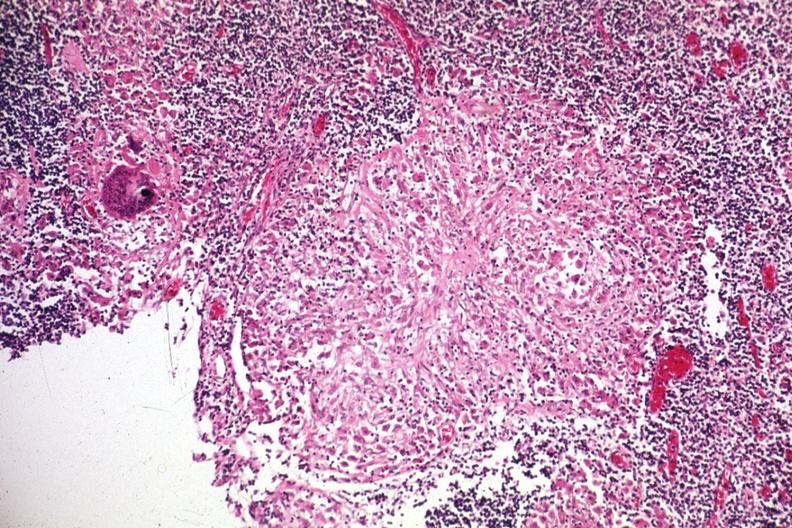s this protocol present?
Answer the question using a single word or phrase. No 